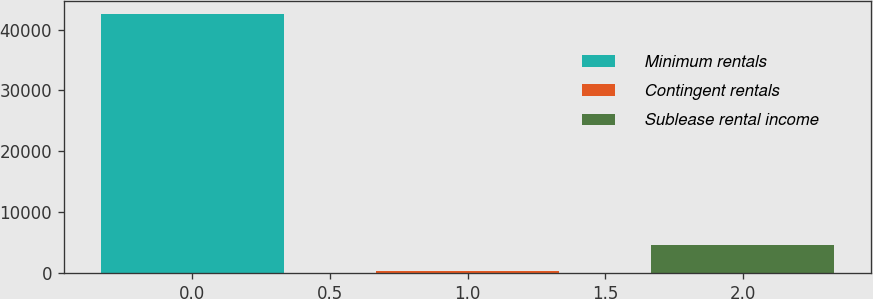<chart> <loc_0><loc_0><loc_500><loc_500><bar_chart><fcel>Minimum rentals<fcel>Contingent rentals<fcel>Sublease rental income<nl><fcel>42506<fcel>431<fcel>4638.5<nl></chart> 